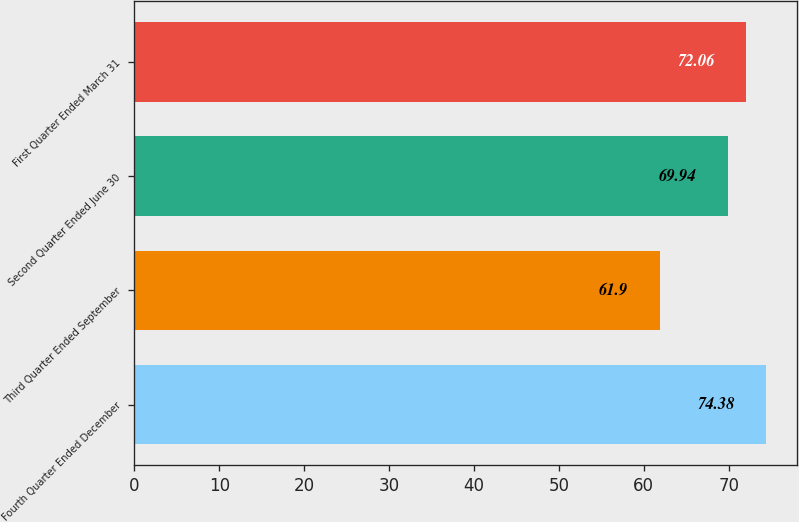<chart> <loc_0><loc_0><loc_500><loc_500><bar_chart><fcel>Fourth Quarter Ended December<fcel>Third Quarter Ended September<fcel>Second Quarter Ended June 30<fcel>First Quarter Ended March 31<nl><fcel>74.38<fcel>61.9<fcel>69.94<fcel>72.06<nl></chart> 